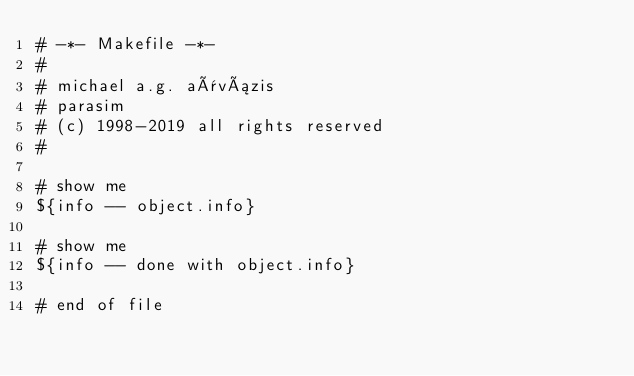<code> <loc_0><loc_0><loc_500><loc_500><_ObjectiveC_># -*- Makefile -*-
#
# michael a.g. aïvázis
# parasim
# (c) 1998-2019 all rights reserved
#

# show me
${info -- object.info}

# show me
${info -- done with object.info}

# end of file
</code> 